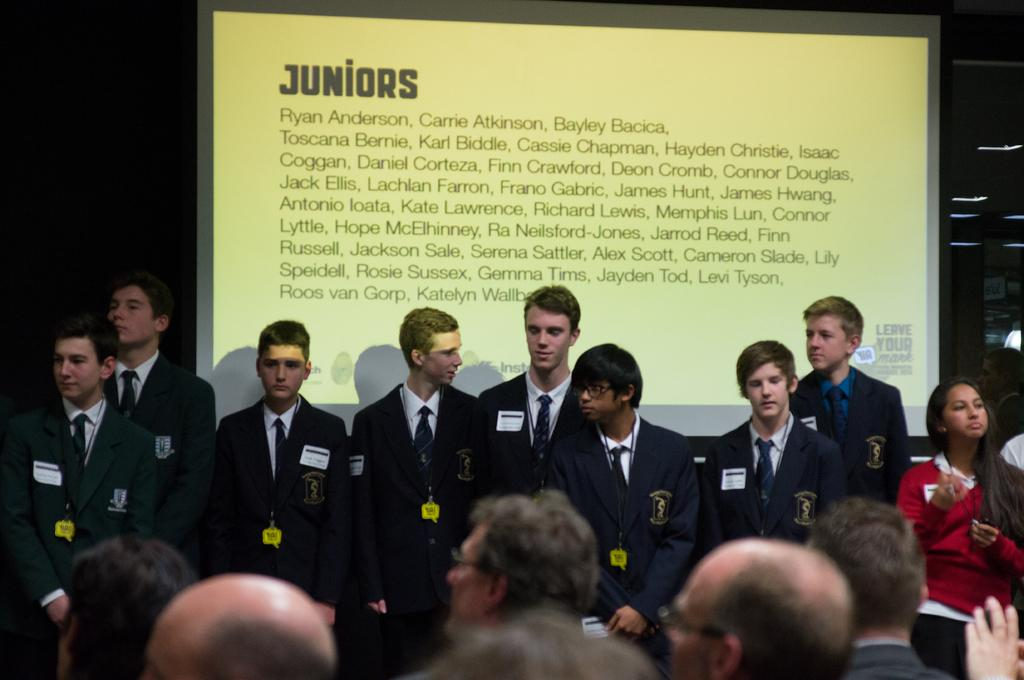How many people are in the group that is visible in the image? There is a group of people standing in the image, but the exact number is not specified. What is located behind the group of people? There is a screen at the back of the group. What is displayed on the screen? There is text on the screen. Where are the lights located in the image? The lights are on the right side of the image. What type of metal is used to construct the hope in the image? There is no mention of hope or any metal in the image. The image features a group of people, a screen, text, and lights. 